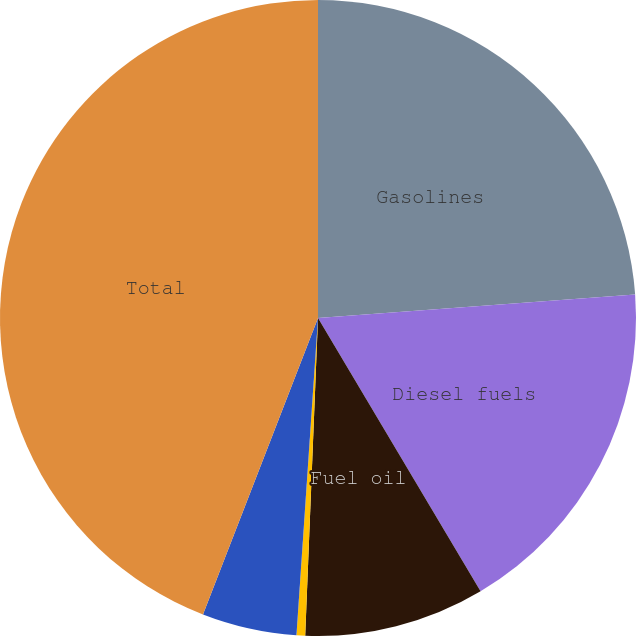Convert chart to OTSL. <chart><loc_0><loc_0><loc_500><loc_500><pie_chart><fcel>Gasolines<fcel>Diesel fuels<fcel>Fuel oil<fcel>Asphalt<fcel>LPG and other<fcel>Total<nl><fcel>23.82%<fcel>17.64%<fcel>9.18%<fcel>0.44%<fcel>4.81%<fcel>44.11%<nl></chart> 